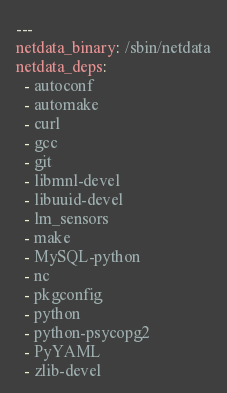<code> <loc_0><loc_0><loc_500><loc_500><_YAML_>---
netdata_binary: /sbin/netdata
netdata_deps:
  - autoconf
  - automake
  - curl
  - gcc
  - git
  - libmnl-devel
  - libuuid-devel
  - lm_sensors
  - make
  - MySQL-python
  - nc
  - pkgconfig
  - python
  - python-psycopg2
  - PyYAML
  - zlib-devel
</code> 